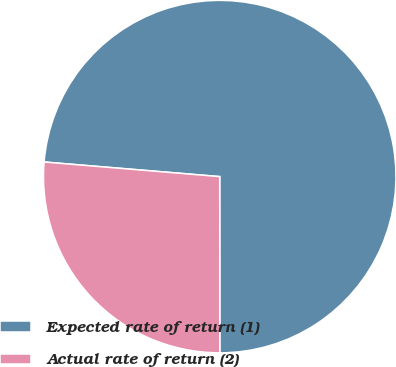Convert chart. <chart><loc_0><loc_0><loc_500><loc_500><pie_chart><fcel>Expected rate of return (1)<fcel>Actual rate of return (2)<nl><fcel>73.67%<fcel>26.33%<nl></chart> 